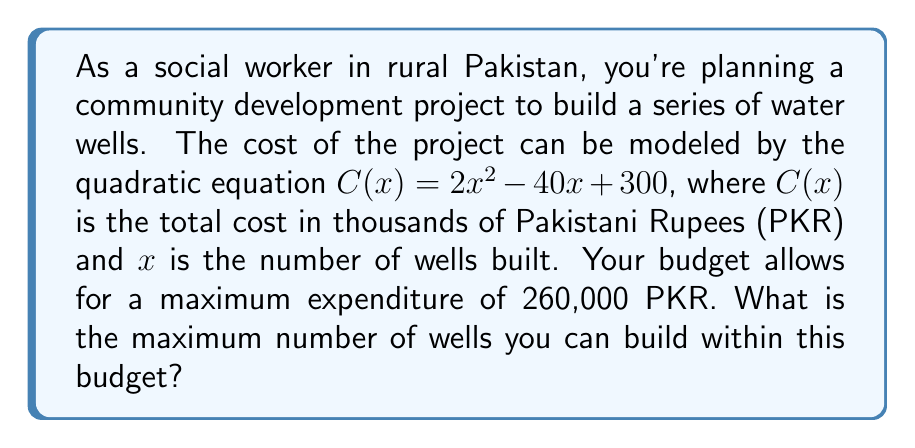Give your solution to this math problem. To solve this problem, we need to follow these steps:

1) First, we need to convert our budget from PKR to thousands of PKR to match the units in the equation. 
   260,000 PKR = 260 thousand PKR

2) Now, we need to set up an inequality using our quadratic equation and the budget limit:
   $2x^2 - 40x + 300 \leq 260$

3) Rearrange the inequality to standard form:
   $2x^2 - 40x + 40 \leq 0$

4) This is a quadratic inequality. To solve it, we first need to find the roots of the corresponding quadratic equation:
   $2x^2 - 40x + 40 = 0$

5) We can solve this using the quadratic formula: $x = \frac{-b \pm \sqrt{b^2 - 4ac}}{2a}$
   Where $a = 2$, $b = -40$, and $c = 40$

6) Plugging these values into the quadratic formula:
   $x = \frac{40 \pm \sqrt{1600 - 320}}{4} = \frac{40 \pm \sqrt{1280}}{4} = \frac{40 \pm 35.78}{4}$

7) This gives us two solutions:
   $x_1 = \frac{40 + 35.78}{4} \approx 18.94$
   $x_2 = \frac{40 - 35.78}{4} \approx 1.06$

8) The inequality $2x^2 - 40x + 40 \leq 0$ is satisfied when $x$ is between these two values.

9) Since we're looking for the maximum number of wells, and $x$ represents the number of wells (which must be a whole number), we round down from 18.94 to 18.
Answer: The maximum number of wells that can be built within the budget is 18. 